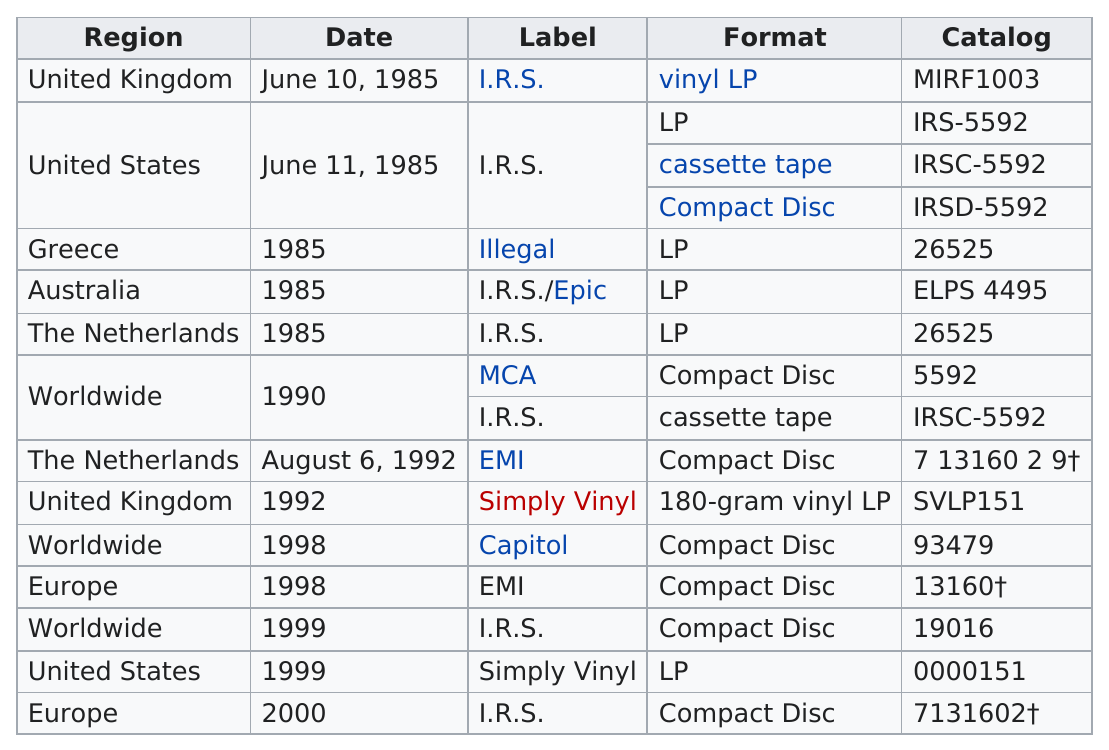List a handful of essential elements in this visual. The country or region with the most releases was worldwide. The first vinyl LP release occurred on June 10, 1985. There were five releases in the compact disc format that exceeded the number of releases in the cassette tape format. The year with the most releases was 1985. The United Kingdom is the only region that offers vinyl LP records. 